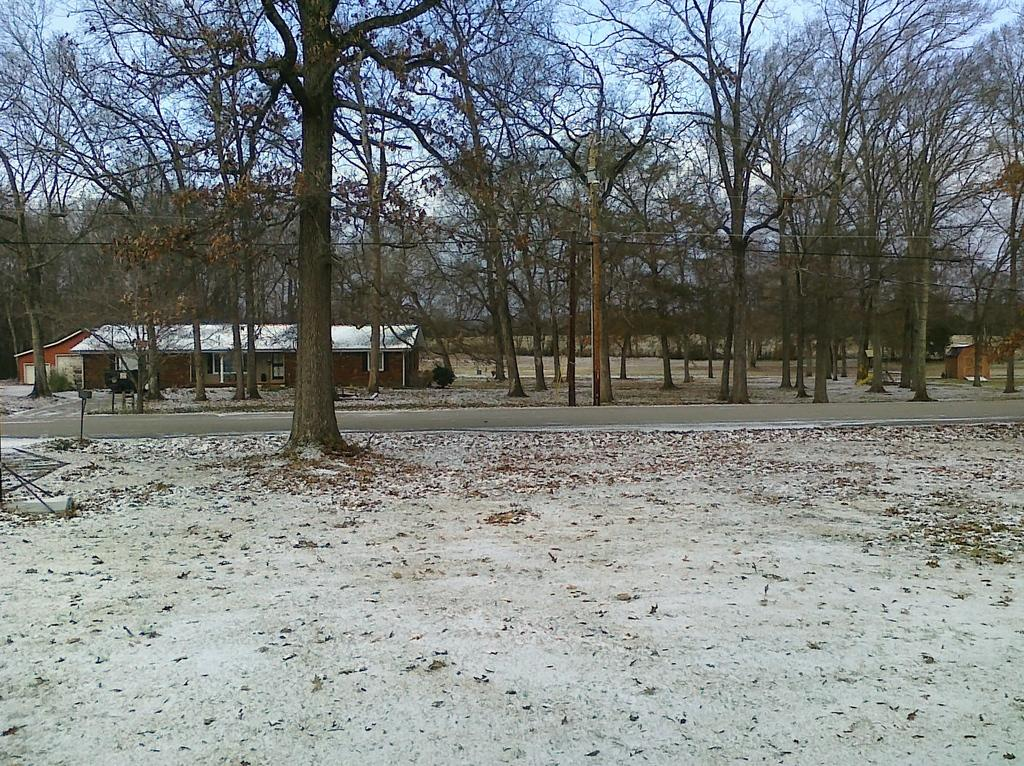What type of natural environment can be seen in the background of the image? There are trees in the background of the image. What type of structures can be seen in the background of the image? There are houses in the background of the image. What sense is being used to experience the garden in the image? There is no garden present in the image, so the question of which sense is being used to experience it is not applicable. 